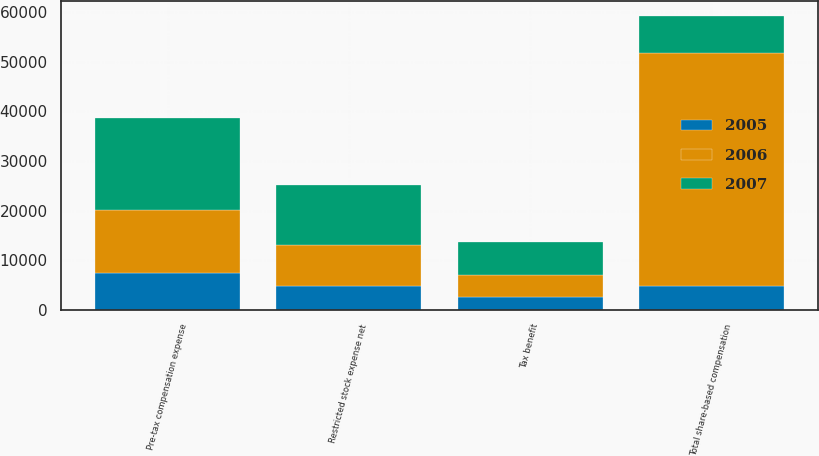Convert chart to OTSL. <chart><loc_0><loc_0><loc_500><loc_500><stacked_bar_chart><ecel><fcel>Pre-tax compensation expense<fcel>Tax benefit<fcel>Restricted stock expense net<fcel>Total share-based compensation<nl><fcel>2007<fcel>18708<fcel>6548<fcel>12160<fcel>7502<nl><fcel>2006<fcel>12561<fcel>4396<fcel>8165<fcel>46854<nl><fcel>2005<fcel>7502<fcel>2626<fcel>4876<fcel>4876<nl></chart> 